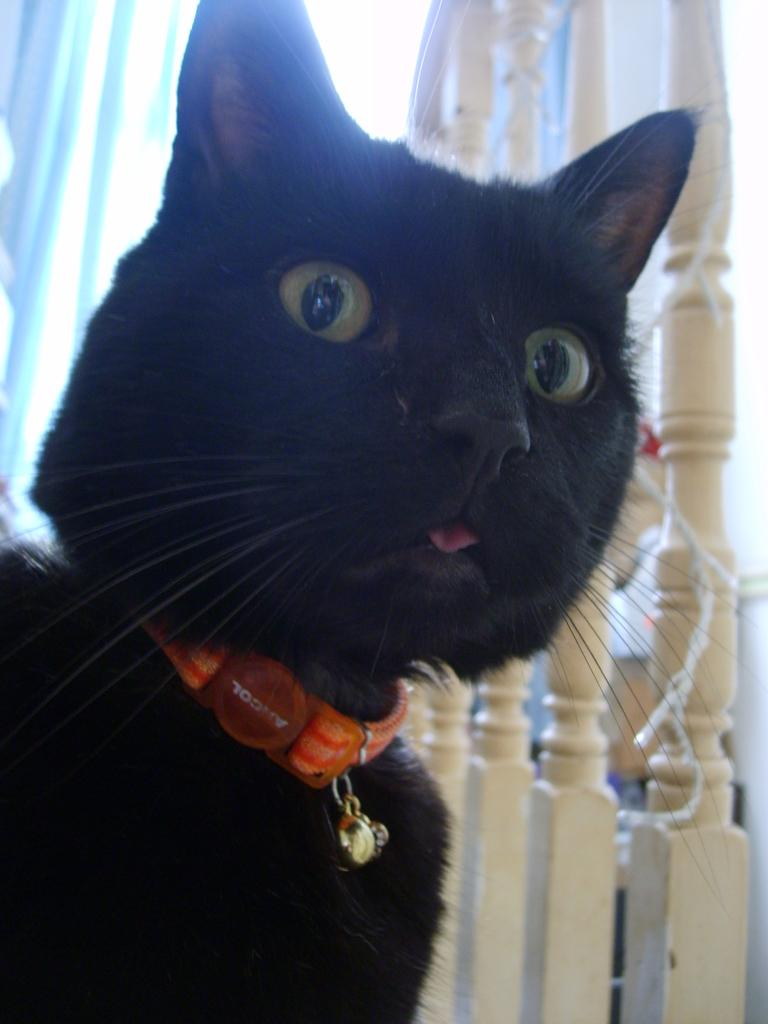What type of animal is on the left side of the image? There is a black cat on the left side of the image. What is the cat wearing around its neck? The cat has a belt around its neck. What can be seen in the background of the image? There are wooden poles, a wall, and a curtain in the background of the image. Are there any other objects visible in the background? Yes, there are other unspecified objects in the background of the image. What type of fowl is sitting on the chairs in the image? There are no chairs or fowl present in the image; it features a black cat with a belt around its neck and a background with wooden poles, a wall, and a curtain. 